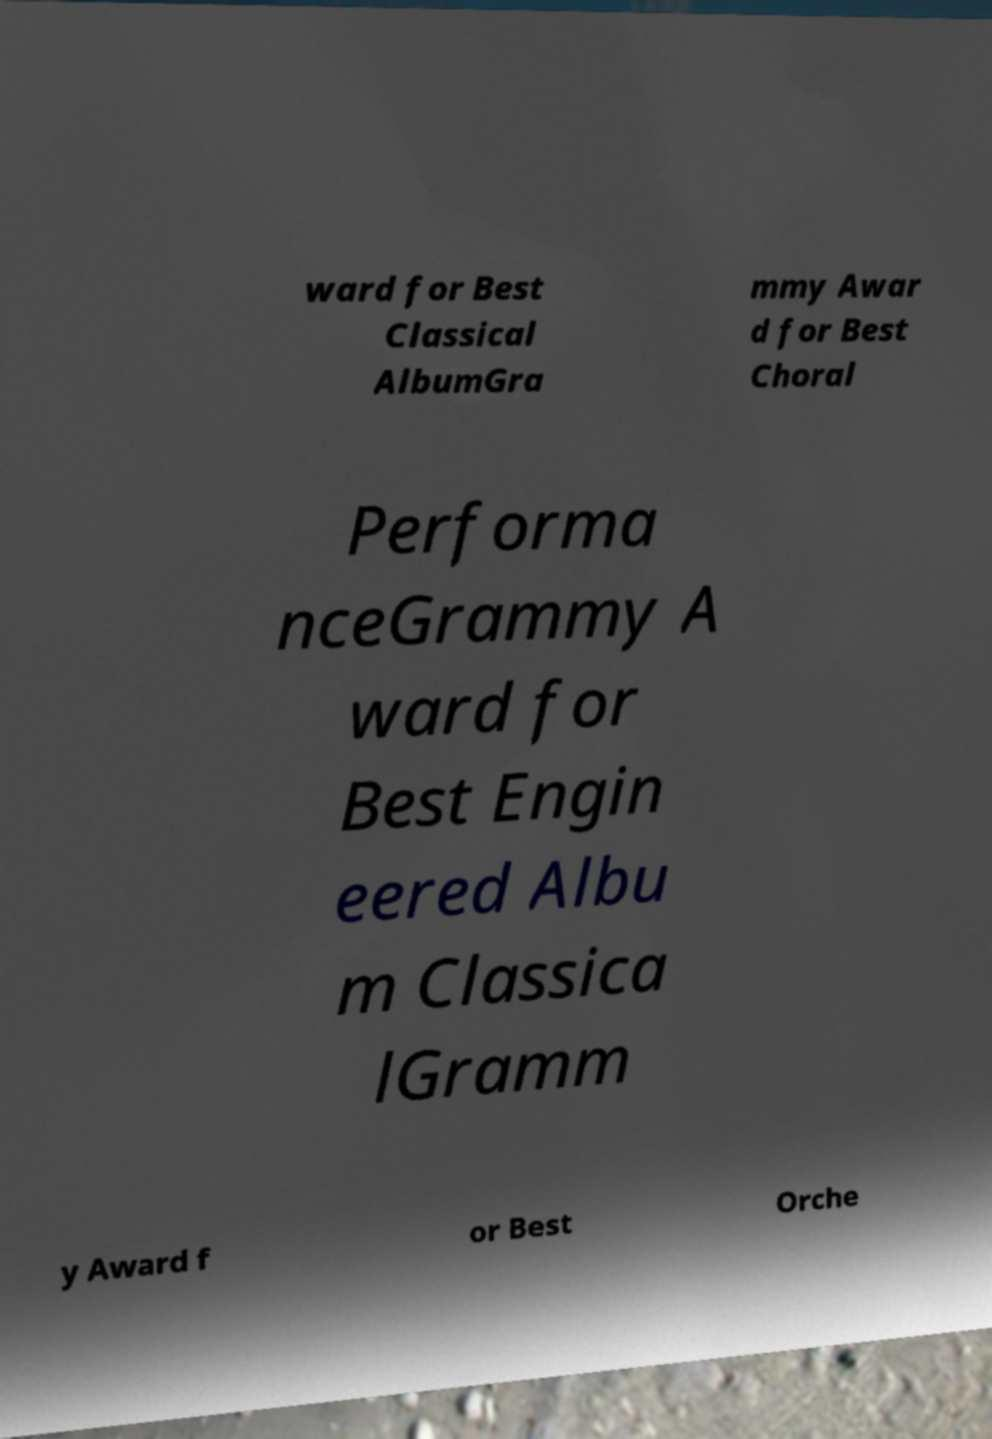There's text embedded in this image that I need extracted. Can you transcribe it verbatim? ward for Best Classical AlbumGra mmy Awar d for Best Choral Performa nceGrammy A ward for Best Engin eered Albu m Classica lGramm y Award f or Best Orche 